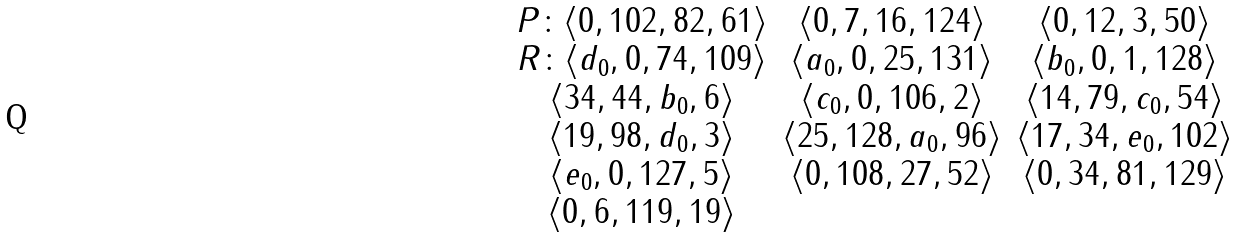Convert formula to latex. <formula><loc_0><loc_0><loc_500><loc_500>\begin{array} { c c c } P \colon \langle 0 , 1 0 2 , 8 2 , 6 1 \rangle & \langle 0 , 7 , 1 6 , 1 2 4 \rangle & \langle 0 , 1 2 , 3 , 5 0 \rangle \\ R \colon \langle d _ { 0 } , 0 , 7 4 , 1 0 9 \rangle & \langle a _ { 0 } , 0 , 2 5 , 1 3 1 \rangle & \langle b _ { 0 } , 0 , 1 , 1 2 8 \rangle \\ \langle 3 4 , 4 4 , b _ { 0 } , 6 \rangle & \langle c _ { 0 } , 0 , 1 0 6 , 2 \rangle & \langle 1 4 , 7 9 , c _ { 0 } , 5 4 \rangle \\ \langle 1 9 , 9 8 , d _ { 0 } , 3 \rangle & \langle 2 5 , 1 2 8 , a _ { 0 } , 9 6 \rangle & \langle 1 7 , 3 4 , e _ { 0 } , 1 0 2 \rangle \\ \langle e _ { 0 } , 0 , 1 2 7 , 5 \rangle & \langle 0 , 1 0 8 , 2 7 , 5 2 \rangle & \langle 0 , 3 4 , 8 1 , 1 2 9 \rangle \\ \langle 0 , 6 , 1 1 9 , 1 9 \rangle \\ \end{array}</formula> 